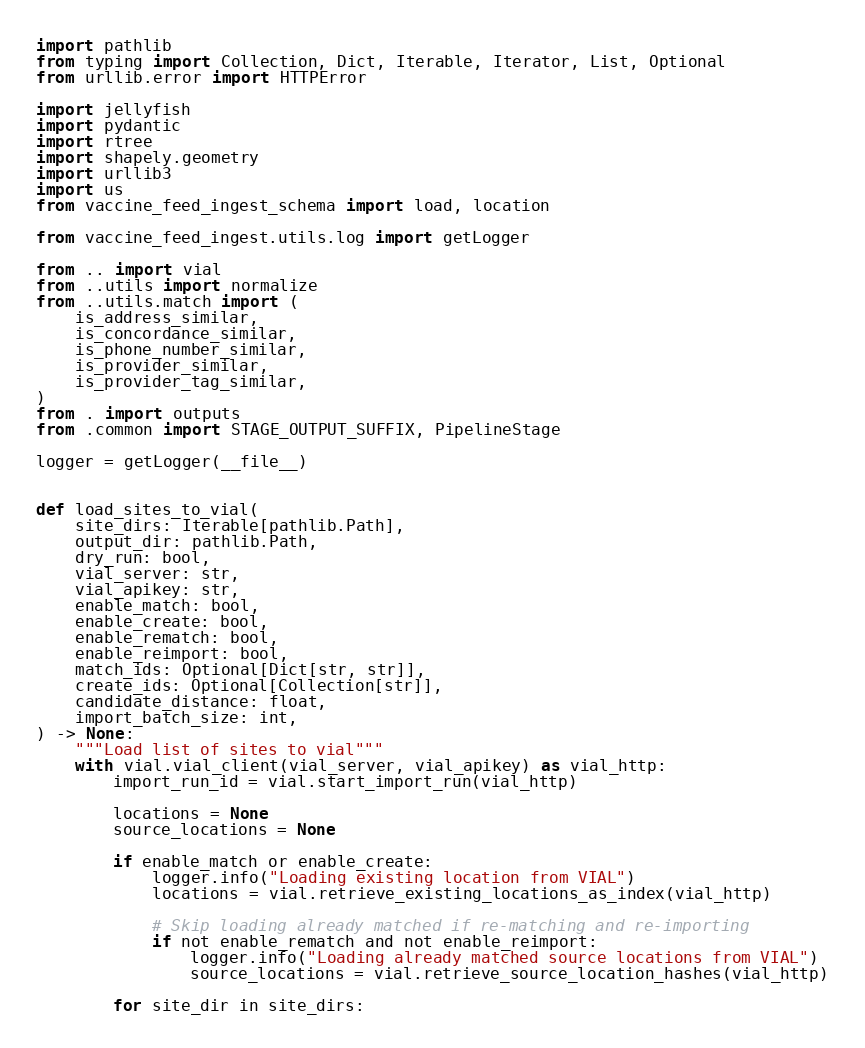Convert code to text. <code><loc_0><loc_0><loc_500><loc_500><_Python_>import pathlib
from typing import Collection, Dict, Iterable, Iterator, List, Optional
from urllib.error import HTTPError

import jellyfish
import pydantic
import rtree
import shapely.geometry
import urllib3
import us
from vaccine_feed_ingest_schema import load, location

from vaccine_feed_ingest.utils.log import getLogger

from .. import vial
from ..utils import normalize
from ..utils.match import (
    is_address_similar,
    is_concordance_similar,
    is_phone_number_similar,
    is_provider_similar,
    is_provider_tag_similar,
)
from . import outputs
from .common import STAGE_OUTPUT_SUFFIX, PipelineStage

logger = getLogger(__file__)


def load_sites_to_vial(
    site_dirs: Iterable[pathlib.Path],
    output_dir: pathlib.Path,
    dry_run: bool,
    vial_server: str,
    vial_apikey: str,
    enable_match: bool,
    enable_create: bool,
    enable_rematch: bool,
    enable_reimport: bool,
    match_ids: Optional[Dict[str, str]],
    create_ids: Optional[Collection[str]],
    candidate_distance: float,
    import_batch_size: int,
) -> None:
    """Load list of sites to vial"""
    with vial.vial_client(vial_server, vial_apikey) as vial_http:
        import_run_id = vial.start_import_run(vial_http)

        locations = None
        source_locations = None

        if enable_match or enable_create:
            logger.info("Loading existing location from VIAL")
            locations = vial.retrieve_existing_locations_as_index(vial_http)

            # Skip loading already matched if re-matching and re-importing
            if not enable_rematch and not enable_reimport:
                logger.info("Loading already matched source locations from VIAL")
                source_locations = vial.retrieve_source_location_hashes(vial_http)

        for site_dir in site_dirs:</code> 